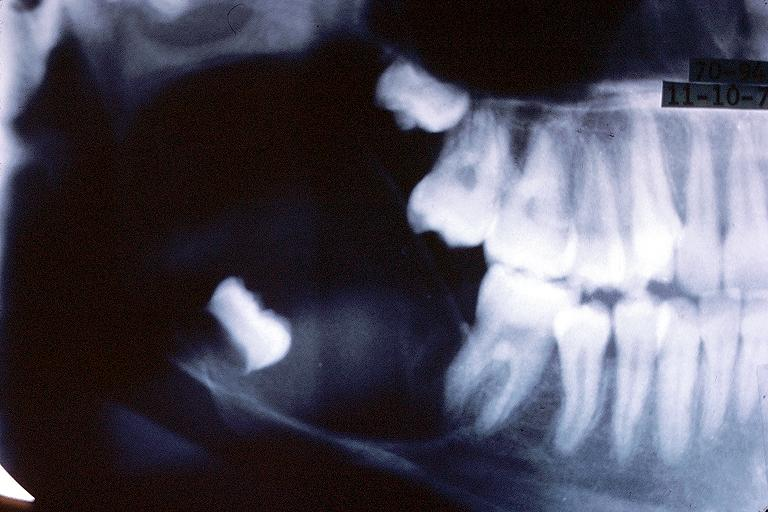what is present?
Answer the question using a single word or phrase. Oral 